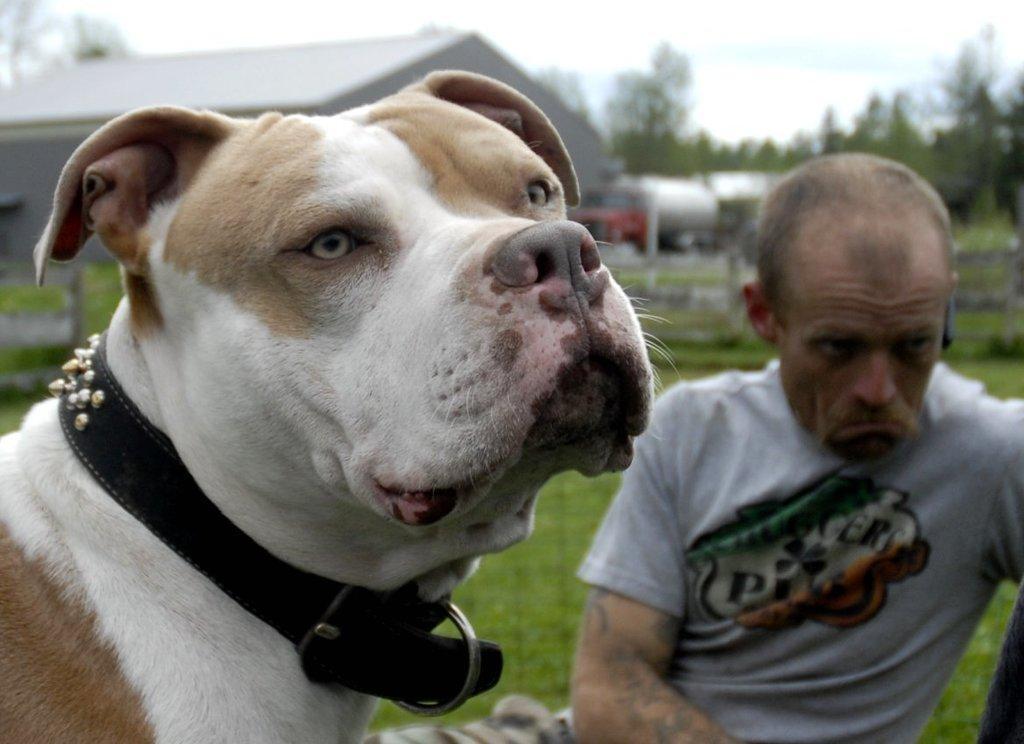How would you summarize this image in a sentence or two? In the picture I can see a dog on the left side. I can see a man on the right side and he is wearing a T-shirt. In the background, I can see the house and trees. 